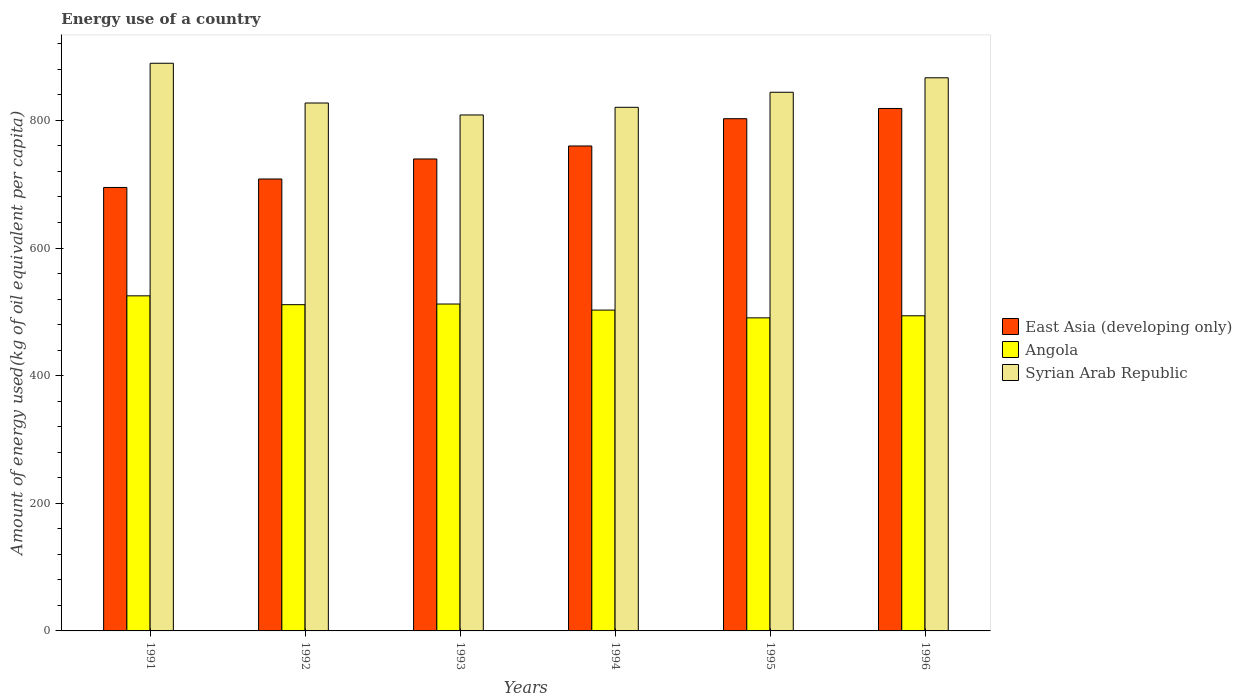How many different coloured bars are there?
Your answer should be very brief. 3. Are the number of bars per tick equal to the number of legend labels?
Give a very brief answer. Yes. Are the number of bars on each tick of the X-axis equal?
Your response must be concise. Yes. How many bars are there on the 1st tick from the left?
Offer a terse response. 3. How many bars are there on the 2nd tick from the right?
Offer a terse response. 3. What is the label of the 2nd group of bars from the left?
Keep it short and to the point. 1992. In how many cases, is the number of bars for a given year not equal to the number of legend labels?
Your answer should be compact. 0. What is the amount of energy used in in Syrian Arab Republic in 1992?
Provide a short and direct response. 827.28. Across all years, what is the maximum amount of energy used in in East Asia (developing only)?
Keep it short and to the point. 818.7. Across all years, what is the minimum amount of energy used in in Angola?
Offer a terse response. 490.61. What is the total amount of energy used in in East Asia (developing only) in the graph?
Provide a short and direct response. 4524.06. What is the difference between the amount of energy used in in East Asia (developing only) in 1992 and that in 1996?
Ensure brevity in your answer.  -110.49. What is the difference between the amount of energy used in in Syrian Arab Republic in 1996 and the amount of energy used in in Angola in 1995?
Ensure brevity in your answer.  376.18. What is the average amount of energy used in in Syrian Arab Republic per year?
Your answer should be compact. 842.81. In the year 1993, what is the difference between the amount of energy used in in East Asia (developing only) and amount of energy used in in Angola?
Give a very brief answer. 227.3. What is the ratio of the amount of energy used in in Angola in 1994 to that in 1996?
Provide a short and direct response. 1.02. Is the amount of energy used in in East Asia (developing only) in 1991 less than that in 1993?
Make the answer very short. Yes. Is the difference between the amount of energy used in in East Asia (developing only) in 1994 and 1995 greater than the difference between the amount of energy used in in Angola in 1994 and 1995?
Keep it short and to the point. No. What is the difference between the highest and the second highest amount of energy used in in East Asia (developing only)?
Offer a terse response. 16.01. What is the difference between the highest and the lowest amount of energy used in in Syrian Arab Republic?
Make the answer very short. 81.03. What does the 3rd bar from the left in 1996 represents?
Provide a succinct answer. Syrian Arab Republic. What does the 3rd bar from the right in 1994 represents?
Your answer should be very brief. East Asia (developing only). Is it the case that in every year, the sum of the amount of energy used in in Syrian Arab Republic and amount of energy used in in Angola is greater than the amount of energy used in in East Asia (developing only)?
Provide a succinct answer. Yes. How many bars are there?
Give a very brief answer. 18. Are all the bars in the graph horizontal?
Offer a terse response. No. How many years are there in the graph?
Provide a short and direct response. 6. What is the difference between two consecutive major ticks on the Y-axis?
Make the answer very short. 200. Does the graph contain any zero values?
Ensure brevity in your answer.  No. Does the graph contain grids?
Your answer should be compact. No. Where does the legend appear in the graph?
Give a very brief answer. Center right. How many legend labels are there?
Make the answer very short. 3. How are the legend labels stacked?
Provide a succinct answer. Vertical. What is the title of the graph?
Provide a succinct answer. Energy use of a country. What is the label or title of the X-axis?
Ensure brevity in your answer.  Years. What is the label or title of the Y-axis?
Provide a succinct answer. Amount of energy used(kg of oil equivalent per capita). What is the Amount of energy used(kg of oil equivalent per capita) of East Asia (developing only) in 1991?
Give a very brief answer. 694.93. What is the Amount of energy used(kg of oil equivalent per capita) in Angola in 1991?
Your response must be concise. 525.1. What is the Amount of energy used(kg of oil equivalent per capita) in Syrian Arab Republic in 1991?
Your response must be concise. 889.57. What is the Amount of energy used(kg of oil equivalent per capita) of East Asia (developing only) in 1992?
Ensure brevity in your answer.  708.21. What is the Amount of energy used(kg of oil equivalent per capita) of Angola in 1992?
Provide a short and direct response. 511.24. What is the Amount of energy used(kg of oil equivalent per capita) of Syrian Arab Republic in 1992?
Keep it short and to the point. 827.28. What is the Amount of energy used(kg of oil equivalent per capita) in East Asia (developing only) in 1993?
Your response must be concise. 739.57. What is the Amount of energy used(kg of oil equivalent per capita) in Angola in 1993?
Your answer should be very brief. 512.27. What is the Amount of energy used(kg of oil equivalent per capita) in Syrian Arab Republic in 1993?
Offer a very short reply. 808.54. What is the Amount of energy used(kg of oil equivalent per capita) of East Asia (developing only) in 1994?
Keep it short and to the point. 759.95. What is the Amount of energy used(kg of oil equivalent per capita) of Angola in 1994?
Provide a short and direct response. 502.78. What is the Amount of energy used(kg of oil equivalent per capita) of Syrian Arab Republic in 1994?
Your answer should be compact. 820.55. What is the Amount of energy used(kg of oil equivalent per capita) in East Asia (developing only) in 1995?
Offer a very short reply. 802.69. What is the Amount of energy used(kg of oil equivalent per capita) of Angola in 1995?
Provide a short and direct response. 490.61. What is the Amount of energy used(kg of oil equivalent per capita) in Syrian Arab Republic in 1995?
Give a very brief answer. 844.13. What is the Amount of energy used(kg of oil equivalent per capita) of East Asia (developing only) in 1996?
Keep it short and to the point. 818.7. What is the Amount of energy used(kg of oil equivalent per capita) in Angola in 1996?
Your response must be concise. 493.84. What is the Amount of energy used(kg of oil equivalent per capita) of Syrian Arab Republic in 1996?
Your answer should be very brief. 866.8. Across all years, what is the maximum Amount of energy used(kg of oil equivalent per capita) of East Asia (developing only)?
Your answer should be compact. 818.7. Across all years, what is the maximum Amount of energy used(kg of oil equivalent per capita) of Angola?
Your answer should be very brief. 525.1. Across all years, what is the maximum Amount of energy used(kg of oil equivalent per capita) of Syrian Arab Republic?
Make the answer very short. 889.57. Across all years, what is the minimum Amount of energy used(kg of oil equivalent per capita) of East Asia (developing only)?
Your answer should be compact. 694.93. Across all years, what is the minimum Amount of energy used(kg of oil equivalent per capita) of Angola?
Your answer should be very brief. 490.61. Across all years, what is the minimum Amount of energy used(kg of oil equivalent per capita) of Syrian Arab Republic?
Give a very brief answer. 808.54. What is the total Amount of energy used(kg of oil equivalent per capita) of East Asia (developing only) in the graph?
Your answer should be compact. 4524.06. What is the total Amount of energy used(kg of oil equivalent per capita) in Angola in the graph?
Ensure brevity in your answer.  3035.85. What is the total Amount of energy used(kg of oil equivalent per capita) of Syrian Arab Republic in the graph?
Provide a short and direct response. 5056.86. What is the difference between the Amount of energy used(kg of oil equivalent per capita) in East Asia (developing only) in 1991 and that in 1992?
Your answer should be compact. -13.28. What is the difference between the Amount of energy used(kg of oil equivalent per capita) of Angola in 1991 and that in 1992?
Provide a short and direct response. 13.86. What is the difference between the Amount of energy used(kg of oil equivalent per capita) in Syrian Arab Republic in 1991 and that in 1992?
Your answer should be compact. 62.3. What is the difference between the Amount of energy used(kg of oil equivalent per capita) in East Asia (developing only) in 1991 and that in 1993?
Your answer should be very brief. -44.64. What is the difference between the Amount of energy used(kg of oil equivalent per capita) in Angola in 1991 and that in 1993?
Give a very brief answer. 12.83. What is the difference between the Amount of energy used(kg of oil equivalent per capita) of Syrian Arab Republic in 1991 and that in 1993?
Offer a very short reply. 81.03. What is the difference between the Amount of energy used(kg of oil equivalent per capita) of East Asia (developing only) in 1991 and that in 1994?
Your answer should be compact. -65.02. What is the difference between the Amount of energy used(kg of oil equivalent per capita) in Angola in 1991 and that in 1994?
Offer a terse response. 22.32. What is the difference between the Amount of energy used(kg of oil equivalent per capita) in Syrian Arab Republic in 1991 and that in 1994?
Give a very brief answer. 69.02. What is the difference between the Amount of energy used(kg of oil equivalent per capita) in East Asia (developing only) in 1991 and that in 1995?
Offer a very short reply. -107.76. What is the difference between the Amount of energy used(kg of oil equivalent per capita) of Angola in 1991 and that in 1995?
Your answer should be very brief. 34.49. What is the difference between the Amount of energy used(kg of oil equivalent per capita) of Syrian Arab Republic in 1991 and that in 1995?
Your response must be concise. 45.44. What is the difference between the Amount of energy used(kg of oil equivalent per capita) of East Asia (developing only) in 1991 and that in 1996?
Your answer should be very brief. -123.77. What is the difference between the Amount of energy used(kg of oil equivalent per capita) in Angola in 1991 and that in 1996?
Ensure brevity in your answer.  31.26. What is the difference between the Amount of energy used(kg of oil equivalent per capita) in Syrian Arab Republic in 1991 and that in 1996?
Offer a terse response. 22.78. What is the difference between the Amount of energy used(kg of oil equivalent per capita) in East Asia (developing only) in 1992 and that in 1993?
Provide a succinct answer. -31.36. What is the difference between the Amount of energy used(kg of oil equivalent per capita) in Angola in 1992 and that in 1993?
Offer a very short reply. -1.03. What is the difference between the Amount of energy used(kg of oil equivalent per capita) in Syrian Arab Republic in 1992 and that in 1993?
Your answer should be compact. 18.73. What is the difference between the Amount of energy used(kg of oil equivalent per capita) in East Asia (developing only) in 1992 and that in 1994?
Keep it short and to the point. -51.73. What is the difference between the Amount of energy used(kg of oil equivalent per capita) in Angola in 1992 and that in 1994?
Your answer should be compact. 8.45. What is the difference between the Amount of energy used(kg of oil equivalent per capita) of Syrian Arab Republic in 1992 and that in 1994?
Keep it short and to the point. 6.73. What is the difference between the Amount of energy used(kg of oil equivalent per capita) in East Asia (developing only) in 1992 and that in 1995?
Offer a very short reply. -94.48. What is the difference between the Amount of energy used(kg of oil equivalent per capita) of Angola in 1992 and that in 1995?
Your answer should be compact. 20.62. What is the difference between the Amount of energy used(kg of oil equivalent per capita) of Syrian Arab Republic in 1992 and that in 1995?
Provide a short and direct response. -16.85. What is the difference between the Amount of energy used(kg of oil equivalent per capita) of East Asia (developing only) in 1992 and that in 1996?
Keep it short and to the point. -110.49. What is the difference between the Amount of energy used(kg of oil equivalent per capita) of Angola in 1992 and that in 1996?
Make the answer very short. 17.4. What is the difference between the Amount of energy used(kg of oil equivalent per capita) of Syrian Arab Republic in 1992 and that in 1996?
Provide a succinct answer. -39.52. What is the difference between the Amount of energy used(kg of oil equivalent per capita) in East Asia (developing only) in 1993 and that in 1994?
Offer a very short reply. -20.37. What is the difference between the Amount of energy used(kg of oil equivalent per capita) of Angola in 1993 and that in 1994?
Your answer should be compact. 9.49. What is the difference between the Amount of energy used(kg of oil equivalent per capita) of Syrian Arab Republic in 1993 and that in 1994?
Your response must be concise. -12.01. What is the difference between the Amount of energy used(kg of oil equivalent per capita) of East Asia (developing only) in 1993 and that in 1995?
Offer a very short reply. -63.12. What is the difference between the Amount of energy used(kg of oil equivalent per capita) in Angola in 1993 and that in 1995?
Offer a terse response. 21.66. What is the difference between the Amount of energy used(kg of oil equivalent per capita) in Syrian Arab Republic in 1993 and that in 1995?
Ensure brevity in your answer.  -35.59. What is the difference between the Amount of energy used(kg of oil equivalent per capita) in East Asia (developing only) in 1993 and that in 1996?
Give a very brief answer. -79.13. What is the difference between the Amount of energy used(kg of oil equivalent per capita) of Angola in 1993 and that in 1996?
Keep it short and to the point. 18.43. What is the difference between the Amount of energy used(kg of oil equivalent per capita) of Syrian Arab Republic in 1993 and that in 1996?
Your answer should be compact. -58.25. What is the difference between the Amount of energy used(kg of oil equivalent per capita) in East Asia (developing only) in 1994 and that in 1995?
Offer a very short reply. -42.74. What is the difference between the Amount of energy used(kg of oil equivalent per capita) in Angola in 1994 and that in 1995?
Keep it short and to the point. 12.17. What is the difference between the Amount of energy used(kg of oil equivalent per capita) of Syrian Arab Republic in 1994 and that in 1995?
Ensure brevity in your answer.  -23.58. What is the difference between the Amount of energy used(kg of oil equivalent per capita) in East Asia (developing only) in 1994 and that in 1996?
Your answer should be compact. -58.76. What is the difference between the Amount of energy used(kg of oil equivalent per capita) in Angola in 1994 and that in 1996?
Offer a terse response. 8.94. What is the difference between the Amount of energy used(kg of oil equivalent per capita) in Syrian Arab Republic in 1994 and that in 1996?
Keep it short and to the point. -46.25. What is the difference between the Amount of energy used(kg of oil equivalent per capita) in East Asia (developing only) in 1995 and that in 1996?
Your answer should be compact. -16.01. What is the difference between the Amount of energy used(kg of oil equivalent per capita) in Angola in 1995 and that in 1996?
Offer a very short reply. -3.23. What is the difference between the Amount of energy used(kg of oil equivalent per capita) in Syrian Arab Republic in 1995 and that in 1996?
Ensure brevity in your answer.  -22.67. What is the difference between the Amount of energy used(kg of oil equivalent per capita) in East Asia (developing only) in 1991 and the Amount of energy used(kg of oil equivalent per capita) in Angola in 1992?
Provide a short and direct response. 183.69. What is the difference between the Amount of energy used(kg of oil equivalent per capita) in East Asia (developing only) in 1991 and the Amount of energy used(kg of oil equivalent per capita) in Syrian Arab Republic in 1992?
Provide a short and direct response. -132.34. What is the difference between the Amount of energy used(kg of oil equivalent per capita) in Angola in 1991 and the Amount of energy used(kg of oil equivalent per capita) in Syrian Arab Republic in 1992?
Ensure brevity in your answer.  -302.17. What is the difference between the Amount of energy used(kg of oil equivalent per capita) of East Asia (developing only) in 1991 and the Amount of energy used(kg of oil equivalent per capita) of Angola in 1993?
Your answer should be very brief. 182.66. What is the difference between the Amount of energy used(kg of oil equivalent per capita) in East Asia (developing only) in 1991 and the Amount of energy used(kg of oil equivalent per capita) in Syrian Arab Republic in 1993?
Your response must be concise. -113.61. What is the difference between the Amount of energy used(kg of oil equivalent per capita) in Angola in 1991 and the Amount of energy used(kg of oil equivalent per capita) in Syrian Arab Republic in 1993?
Your response must be concise. -283.44. What is the difference between the Amount of energy used(kg of oil equivalent per capita) in East Asia (developing only) in 1991 and the Amount of energy used(kg of oil equivalent per capita) in Angola in 1994?
Give a very brief answer. 192.15. What is the difference between the Amount of energy used(kg of oil equivalent per capita) of East Asia (developing only) in 1991 and the Amount of energy used(kg of oil equivalent per capita) of Syrian Arab Republic in 1994?
Ensure brevity in your answer.  -125.62. What is the difference between the Amount of energy used(kg of oil equivalent per capita) in Angola in 1991 and the Amount of energy used(kg of oil equivalent per capita) in Syrian Arab Republic in 1994?
Ensure brevity in your answer.  -295.45. What is the difference between the Amount of energy used(kg of oil equivalent per capita) of East Asia (developing only) in 1991 and the Amount of energy used(kg of oil equivalent per capita) of Angola in 1995?
Provide a succinct answer. 204.32. What is the difference between the Amount of energy used(kg of oil equivalent per capita) in East Asia (developing only) in 1991 and the Amount of energy used(kg of oil equivalent per capita) in Syrian Arab Republic in 1995?
Keep it short and to the point. -149.2. What is the difference between the Amount of energy used(kg of oil equivalent per capita) of Angola in 1991 and the Amount of energy used(kg of oil equivalent per capita) of Syrian Arab Republic in 1995?
Make the answer very short. -319.03. What is the difference between the Amount of energy used(kg of oil equivalent per capita) of East Asia (developing only) in 1991 and the Amount of energy used(kg of oil equivalent per capita) of Angola in 1996?
Keep it short and to the point. 201.09. What is the difference between the Amount of energy used(kg of oil equivalent per capita) of East Asia (developing only) in 1991 and the Amount of energy used(kg of oil equivalent per capita) of Syrian Arab Republic in 1996?
Provide a succinct answer. -171.87. What is the difference between the Amount of energy used(kg of oil equivalent per capita) in Angola in 1991 and the Amount of energy used(kg of oil equivalent per capita) in Syrian Arab Republic in 1996?
Your answer should be compact. -341.7. What is the difference between the Amount of energy used(kg of oil equivalent per capita) in East Asia (developing only) in 1992 and the Amount of energy used(kg of oil equivalent per capita) in Angola in 1993?
Give a very brief answer. 195.94. What is the difference between the Amount of energy used(kg of oil equivalent per capita) of East Asia (developing only) in 1992 and the Amount of energy used(kg of oil equivalent per capita) of Syrian Arab Republic in 1993?
Your answer should be compact. -100.33. What is the difference between the Amount of energy used(kg of oil equivalent per capita) of Angola in 1992 and the Amount of energy used(kg of oil equivalent per capita) of Syrian Arab Republic in 1993?
Offer a terse response. -297.31. What is the difference between the Amount of energy used(kg of oil equivalent per capita) of East Asia (developing only) in 1992 and the Amount of energy used(kg of oil equivalent per capita) of Angola in 1994?
Ensure brevity in your answer.  205.43. What is the difference between the Amount of energy used(kg of oil equivalent per capita) of East Asia (developing only) in 1992 and the Amount of energy used(kg of oil equivalent per capita) of Syrian Arab Republic in 1994?
Give a very brief answer. -112.33. What is the difference between the Amount of energy used(kg of oil equivalent per capita) of Angola in 1992 and the Amount of energy used(kg of oil equivalent per capita) of Syrian Arab Republic in 1994?
Offer a very short reply. -309.31. What is the difference between the Amount of energy used(kg of oil equivalent per capita) of East Asia (developing only) in 1992 and the Amount of energy used(kg of oil equivalent per capita) of Angola in 1995?
Offer a terse response. 217.6. What is the difference between the Amount of energy used(kg of oil equivalent per capita) in East Asia (developing only) in 1992 and the Amount of energy used(kg of oil equivalent per capita) in Syrian Arab Republic in 1995?
Ensure brevity in your answer.  -135.91. What is the difference between the Amount of energy used(kg of oil equivalent per capita) of Angola in 1992 and the Amount of energy used(kg of oil equivalent per capita) of Syrian Arab Republic in 1995?
Your response must be concise. -332.89. What is the difference between the Amount of energy used(kg of oil equivalent per capita) of East Asia (developing only) in 1992 and the Amount of energy used(kg of oil equivalent per capita) of Angola in 1996?
Provide a succinct answer. 214.37. What is the difference between the Amount of energy used(kg of oil equivalent per capita) in East Asia (developing only) in 1992 and the Amount of energy used(kg of oil equivalent per capita) in Syrian Arab Republic in 1996?
Your response must be concise. -158.58. What is the difference between the Amount of energy used(kg of oil equivalent per capita) of Angola in 1992 and the Amount of energy used(kg of oil equivalent per capita) of Syrian Arab Republic in 1996?
Your response must be concise. -355.56. What is the difference between the Amount of energy used(kg of oil equivalent per capita) of East Asia (developing only) in 1993 and the Amount of energy used(kg of oil equivalent per capita) of Angola in 1994?
Give a very brief answer. 236.79. What is the difference between the Amount of energy used(kg of oil equivalent per capita) in East Asia (developing only) in 1993 and the Amount of energy used(kg of oil equivalent per capita) in Syrian Arab Republic in 1994?
Offer a very short reply. -80.98. What is the difference between the Amount of energy used(kg of oil equivalent per capita) in Angola in 1993 and the Amount of energy used(kg of oil equivalent per capita) in Syrian Arab Republic in 1994?
Keep it short and to the point. -308.28. What is the difference between the Amount of energy used(kg of oil equivalent per capita) of East Asia (developing only) in 1993 and the Amount of energy used(kg of oil equivalent per capita) of Angola in 1995?
Your answer should be very brief. 248.96. What is the difference between the Amount of energy used(kg of oil equivalent per capita) in East Asia (developing only) in 1993 and the Amount of energy used(kg of oil equivalent per capita) in Syrian Arab Republic in 1995?
Keep it short and to the point. -104.56. What is the difference between the Amount of energy used(kg of oil equivalent per capita) of Angola in 1993 and the Amount of energy used(kg of oil equivalent per capita) of Syrian Arab Republic in 1995?
Ensure brevity in your answer.  -331.86. What is the difference between the Amount of energy used(kg of oil equivalent per capita) of East Asia (developing only) in 1993 and the Amount of energy used(kg of oil equivalent per capita) of Angola in 1996?
Provide a succinct answer. 245.73. What is the difference between the Amount of energy used(kg of oil equivalent per capita) of East Asia (developing only) in 1993 and the Amount of energy used(kg of oil equivalent per capita) of Syrian Arab Republic in 1996?
Provide a succinct answer. -127.22. What is the difference between the Amount of energy used(kg of oil equivalent per capita) in Angola in 1993 and the Amount of energy used(kg of oil equivalent per capita) in Syrian Arab Republic in 1996?
Provide a succinct answer. -354.53. What is the difference between the Amount of energy used(kg of oil equivalent per capita) in East Asia (developing only) in 1994 and the Amount of energy used(kg of oil equivalent per capita) in Angola in 1995?
Your answer should be very brief. 269.33. What is the difference between the Amount of energy used(kg of oil equivalent per capita) in East Asia (developing only) in 1994 and the Amount of energy used(kg of oil equivalent per capita) in Syrian Arab Republic in 1995?
Keep it short and to the point. -84.18. What is the difference between the Amount of energy used(kg of oil equivalent per capita) in Angola in 1994 and the Amount of energy used(kg of oil equivalent per capita) in Syrian Arab Republic in 1995?
Give a very brief answer. -341.35. What is the difference between the Amount of energy used(kg of oil equivalent per capita) in East Asia (developing only) in 1994 and the Amount of energy used(kg of oil equivalent per capita) in Angola in 1996?
Make the answer very short. 266.11. What is the difference between the Amount of energy used(kg of oil equivalent per capita) of East Asia (developing only) in 1994 and the Amount of energy used(kg of oil equivalent per capita) of Syrian Arab Republic in 1996?
Provide a succinct answer. -106.85. What is the difference between the Amount of energy used(kg of oil equivalent per capita) of Angola in 1994 and the Amount of energy used(kg of oil equivalent per capita) of Syrian Arab Republic in 1996?
Give a very brief answer. -364.01. What is the difference between the Amount of energy used(kg of oil equivalent per capita) of East Asia (developing only) in 1995 and the Amount of energy used(kg of oil equivalent per capita) of Angola in 1996?
Your response must be concise. 308.85. What is the difference between the Amount of energy used(kg of oil equivalent per capita) in East Asia (developing only) in 1995 and the Amount of energy used(kg of oil equivalent per capita) in Syrian Arab Republic in 1996?
Make the answer very short. -64.1. What is the difference between the Amount of energy used(kg of oil equivalent per capita) in Angola in 1995 and the Amount of energy used(kg of oil equivalent per capita) in Syrian Arab Republic in 1996?
Your answer should be compact. -376.18. What is the average Amount of energy used(kg of oil equivalent per capita) in East Asia (developing only) per year?
Provide a succinct answer. 754.01. What is the average Amount of energy used(kg of oil equivalent per capita) of Angola per year?
Give a very brief answer. 505.97. What is the average Amount of energy used(kg of oil equivalent per capita) of Syrian Arab Republic per year?
Offer a terse response. 842.81. In the year 1991, what is the difference between the Amount of energy used(kg of oil equivalent per capita) in East Asia (developing only) and Amount of energy used(kg of oil equivalent per capita) in Angola?
Provide a succinct answer. 169.83. In the year 1991, what is the difference between the Amount of energy used(kg of oil equivalent per capita) in East Asia (developing only) and Amount of energy used(kg of oil equivalent per capita) in Syrian Arab Republic?
Your answer should be very brief. -194.64. In the year 1991, what is the difference between the Amount of energy used(kg of oil equivalent per capita) of Angola and Amount of energy used(kg of oil equivalent per capita) of Syrian Arab Republic?
Provide a succinct answer. -364.47. In the year 1992, what is the difference between the Amount of energy used(kg of oil equivalent per capita) of East Asia (developing only) and Amount of energy used(kg of oil equivalent per capita) of Angola?
Your answer should be very brief. 196.98. In the year 1992, what is the difference between the Amount of energy used(kg of oil equivalent per capita) in East Asia (developing only) and Amount of energy used(kg of oil equivalent per capita) in Syrian Arab Republic?
Make the answer very short. -119.06. In the year 1992, what is the difference between the Amount of energy used(kg of oil equivalent per capita) of Angola and Amount of energy used(kg of oil equivalent per capita) of Syrian Arab Republic?
Offer a terse response. -316.04. In the year 1993, what is the difference between the Amount of energy used(kg of oil equivalent per capita) of East Asia (developing only) and Amount of energy used(kg of oil equivalent per capita) of Angola?
Your answer should be compact. 227.3. In the year 1993, what is the difference between the Amount of energy used(kg of oil equivalent per capita) in East Asia (developing only) and Amount of energy used(kg of oil equivalent per capita) in Syrian Arab Republic?
Your answer should be very brief. -68.97. In the year 1993, what is the difference between the Amount of energy used(kg of oil equivalent per capita) in Angola and Amount of energy used(kg of oil equivalent per capita) in Syrian Arab Republic?
Provide a short and direct response. -296.27. In the year 1994, what is the difference between the Amount of energy used(kg of oil equivalent per capita) in East Asia (developing only) and Amount of energy used(kg of oil equivalent per capita) in Angola?
Offer a very short reply. 257.17. In the year 1994, what is the difference between the Amount of energy used(kg of oil equivalent per capita) of East Asia (developing only) and Amount of energy used(kg of oil equivalent per capita) of Syrian Arab Republic?
Your response must be concise. -60.6. In the year 1994, what is the difference between the Amount of energy used(kg of oil equivalent per capita) of Angola and Amount of energy used(kg of oil equivalent per capita) of Syrian Arab Republic?
Your answer should be compact. -317.77. In the year 1995, what is the difference between the Amount of energy used(kg of oil equivalent per capita) in East Asia (developing only) and Amount of energy used(kg of oil equivalent per capita) in Angola?
Your answer should be compact. 312.08. In the year 1995, what is the difference between the Amount of energy used(kg of oil equivalent per capita) in East Asia (developing only) and Amount of energy used(kg of oil equivalent per capita) in Syrian Arab Republic?
Provide a succinct answer. -41.44. In the year 1995, what is the difference between the Amount of energy used(kg of oil equivalent per capita) of Angola and Amount of energy used(kg of oil equivalent per capita) of Syrian Arab Republic?
Provide a short and direct response. -353.51. In the year 1996, what is the difference between the Amount of energy used(kg of oil equivalent per capita) of East Asia (developing only) and Amount of energy used(kg of oil equivalent per capita) of Angola?
Give a very brief answer. 324.86. In the year 1996, what is the difference between the Amount of energy used(kg of oil equivalent per capita) in East Asia (developing only) and Amount of energy used(kg of oil equivalent per capita) in Syrian Arab Republic?
Your response must be concise. -48.09. In the year 1996, what is the difference between the Amount of energy used(kg of oil equivalent per capita) in Angola and Amount of energy used(kg of oil equivalent per capita) in Syrian Arab Republic?
Your response must be concise. -372.95. What is the ratio of the Amount of energy used(kg of oil equivalent per capita) in East Asia (developing only) in 1991 to that in 1992?
Provide a succinct answer. 0.98. What is the ratio of the Amount of energy used(kg of oil equivalent per capita) in Angola in 1991 to that in 1992?
Your answer should be compact. 1.03. What is the ratio of the Amount of energy used(kg of oil equivalent per capita) of Syrian Arab Republic in 1991 to that in 1992?
Your answer should be compact. 1.08. What is the ratio of the Amount of energy used(kg of oil equivalent per capita) of East Asia (developing only) in 1991 to that in 1993?
Your answer should be compact. 0.94. What is the ratio of the Amount of energy used(kg of oil equivalent per capita) in Syrian Arab Republic in 1991 to that in 1993?
Provide a succinct answer. 1.1. What is the ratio of the Amount of energy used(kg of oil equivalent per capita) of East Asia (developing only) in 1991 to that in 1994?
Offer a very short reply. 0.91. What is the ratio of the Amount of energy used(kg of oil equivalent per capita) of Angola in 1991 to that in 1994?
Provide a succinct answer. 1.04. What is the ratio of the Amount of energy used(kg of oil equivalent per capita) in Syrian Arab Republic in 1991 to that in 1994?
Your response must be concise. 1.08. What is the ratio of the Amount of energy used(kg of oil equivalent per capita) of East Asia (developing only) in 1991 to that in 1995?
Give a very brief answer. 0.87. What is the ratio of the Amount of energy used(kg of oil equivalent per capita) in Angola in 1991 to that in 1995?
Offer a very short reply. 1.07. What is the ratio of the Amount of energy used(kg of oil equivalent per capita) in Syrian Arab Republic in 1991 to that in 1995?
Provide a succinct answer. 1.05. What is the ratio of the Amount of energy used(kg of oil equivalent per capita) in East Asia (developing only) in 1991 to that in 1996?
Your response must be concise. 0.85. What is the ratio of the Amount of energy used(kg of oil equivalent per capita) in Angola in 1991 to that in 1996?
Your answer should be very brief. 1.06. What is the ratio of the Amount of energy used(kg of oil equivalent per capita) in Syrian Arab Republic in 1991 to that in 1996?
Your response must be concise. 1.03. What is the ratio of the Amount of energy used(kg of oil equivalent per capita) in East Asia (developing only) in 1992 to that in 1993?
Your response must be concise. 0.96. What is the ratio of the Amount of energy used(kg of oil equivalent per capita) of Angola in 1992 to that in 1993?
Provide a short and direct response. 1. What is the ratio of the Amount of energy used(kg of oil equivalent per capita) of Syrian Arab Republic in 1992 to that in 1993?
Provide a short and direct response. 1.02. What is the ratio of the Amount of energy used(kg of oil equivalent per capita) in East Asia (developing only) in 1992 to that in 1994?
Give a very brief answer. 0.93. What is the ratio of the Amount of energy used(kg of oil equivalent per capita) in Angola in 1992 to that in 1994?
Your response must be concise. 1.02. What is the ratio of the Amount of energy used(kg of oil equivalent per capita) of Syrian Arab Republic in 1992 to that in 1994?
Your answer should be very brief. 1.01. What is the ratio of the Amount of energy used(kg of oil equivalent per capita) in East Asia (developing only) in 1992 to that in 1995?
Give a very brief answer. 0.88. What is the ratio of the Amount of energy used(kg of oil equivalent per capita) in Angola in 1992 to that in 1995?
Offer a very short reply. 1.04. What is the ratio of the Amount of energy used(kg of oil equivalent per capita) in East Asia (developing only) in 1992 to that in 1996?
Make the answer very short. 0.86. What is the ratio of the Amount of energy used(kg of oil equivalent per capita) in Angola in 1992 to that in 1996?
Offer a terse response. 1.04. What is the ratio of the Amount of energy used(kg of oil equivalent per capita) in Syrian Arab Republic in 1992 to that in 1996?
Keep it short and to the point. 0.95. What is the ratio of the Amount of energy used(kg of oil equivalent per capita) of East Asia (developing only) in 1993 to that in 1994?
Make the answer very short. 0.97. What is the ratio of the Amount of energy used(kg of oil equivalent per capita) of Angola in 1993 to that in 1994?
Make the answer very short. 1.02. What is the ratio of the Amount of energy used(kg of oil equivalent per capita) of Syrian Arab Republic in 1993 to that in 1994?
Make the answer very short. 0.99. What is the ratio of the Amount of energy used(kg of oil equivalent per capita) of East Asia (developing only) in 1993 to that in 1995?
Ensure brevity in your answer.  0.92. What is the ratio of the Amount of energy used(kg of oil equivalent per capita) in Angola in 1993 to that in 1995?
Provide a short and direct response. 1.04. What is the ratio of the Amount of energy used(kg of oil equivalent per capita) of Syrian Arab Republic in 1993 to that in 1995?
Offer a very short reply. 0.96. What is the ratio of the Amount of energy used(kg of oil equivalent per capita) in East Asia (developing only) in 1993 to that in 1996?
Your response must be concise. 0.9. What is the ratio of the Amount of energy used(kg of oil equivalent per capita) in Angola in 1993 to that in 1996?
Keep it short and to the point. 1.04. What is the ratio of the Amount of energy used(kg of oil equivalent per capita) in Syrian Arab Republic in 1993 to that in 1996?
Give a very brief answer. 0.93. What is the ratio of the Amount of energy used(kg of oil equivalent per capita) in East Asia (developing only) in 1994 to that in 1995?
Your answer should be compact. 0.95. What is the ratio of the Amount of energy used(kg of oil equivalent per capita) in Angola in 1994 to that in 1995?
Give a very brief answer. 1.02. What is the ratio of the Amount of energy used(kg of oil equivalent per capita) in Syrian Arab Republic in 1994 to that in 1995?
Make the answer very short. 0.97. What is the ratio of the Amount of energy used(kg of oil equivalent per capita) of East Asia (developing only) in 1994 to that in 1996?
Keep it short and to the point. 0.93. What is the ratio of the Amount of energy used(kg of oil equivalent per capita) in Angola in 1994 to that in 1996?
Offer a very short reply. 1.02. What is the ratio of the Amount of energy used(kg of oil equivalent per capita) in Syrian Arab Republic in 1994 to that in 1996?
Offer a very short reply. 0.95. What is the ratio of the Amount of energy used(kg of oil equivalent per capita) of East Asia (developing only) in 1995 to that in 1996?
Make the answer very short. 0.98. What is the ratio of the Amount of energy used(kg of oil equivalent per capita) of Syrian Arab Republic in 1995 to that in 1996?
Make the answer very short. 0.97. What is the difference between the highest and the second highest Amount of energy used(kg of oil equivalent per capita) of East Asia (developing only)?
Offer a terse response. 16.01. What is the difference between the highest and the second highest Amount of energy used(kg of oil equivalent per capita) of Angola?
Offer a terse response. 12.83. What is the difference between the highest and the second highest Amount of energy used(kg of oil equivalent per capita) in Syrian Arab Republic?
Your response must be concise. 22.78. What is the difference between the highest and the lowest Amount of energy used(kg of oil equivalent per capita) in East Asia (developing only)?
Ensure brevity in your answer.  123.77. What is the difference between the highest and the lowest Amount of energy used(kg of oil equivalent per capita) of Angola?
Your answer should be compact. 34.49. What is the difference between the highest and the lowest Amount of energy used(kg of oil equivalent per capita) in Syrian Arab Republic?
Your answer should be compact. 81.03. 